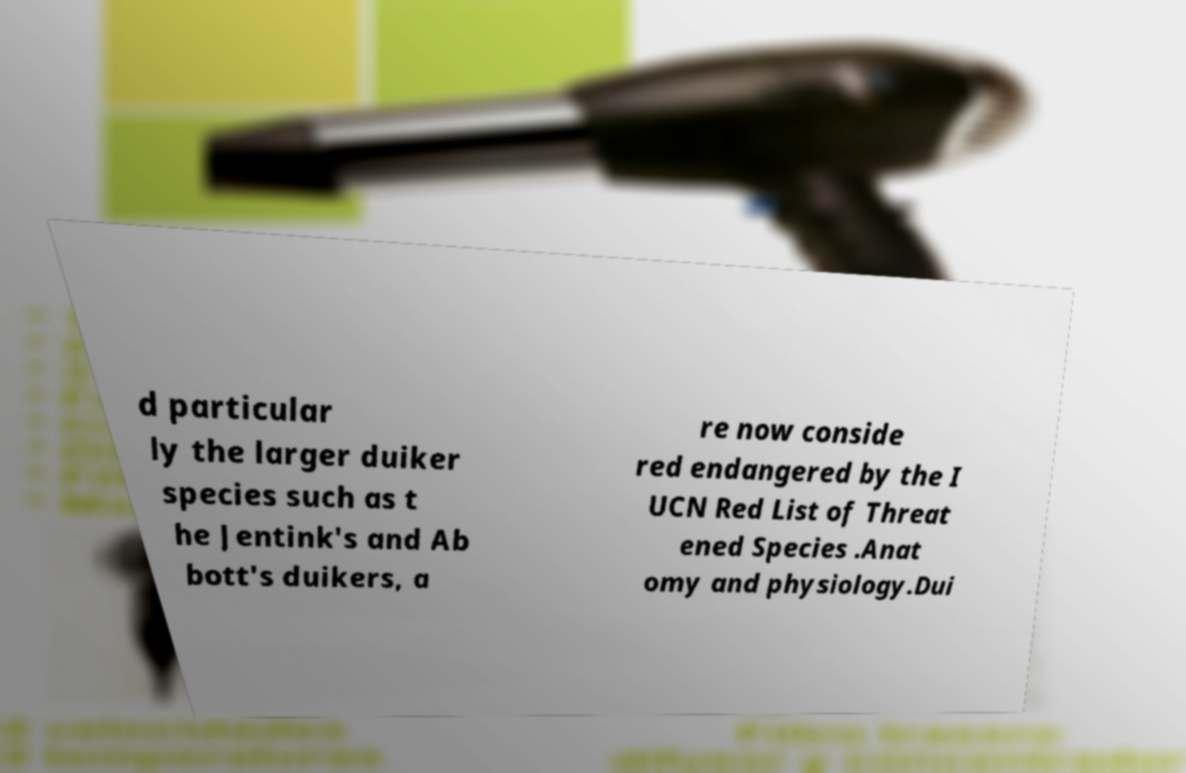Could you assist in decoding the text presented in this image and type it out clearly? d particular ly the larger duiker species such as t he Jentink's and Ab bott's duikers, a re now conside red endangered by the I UCN Red List of Threat ened Species .Anat omy and physiology.Dui 